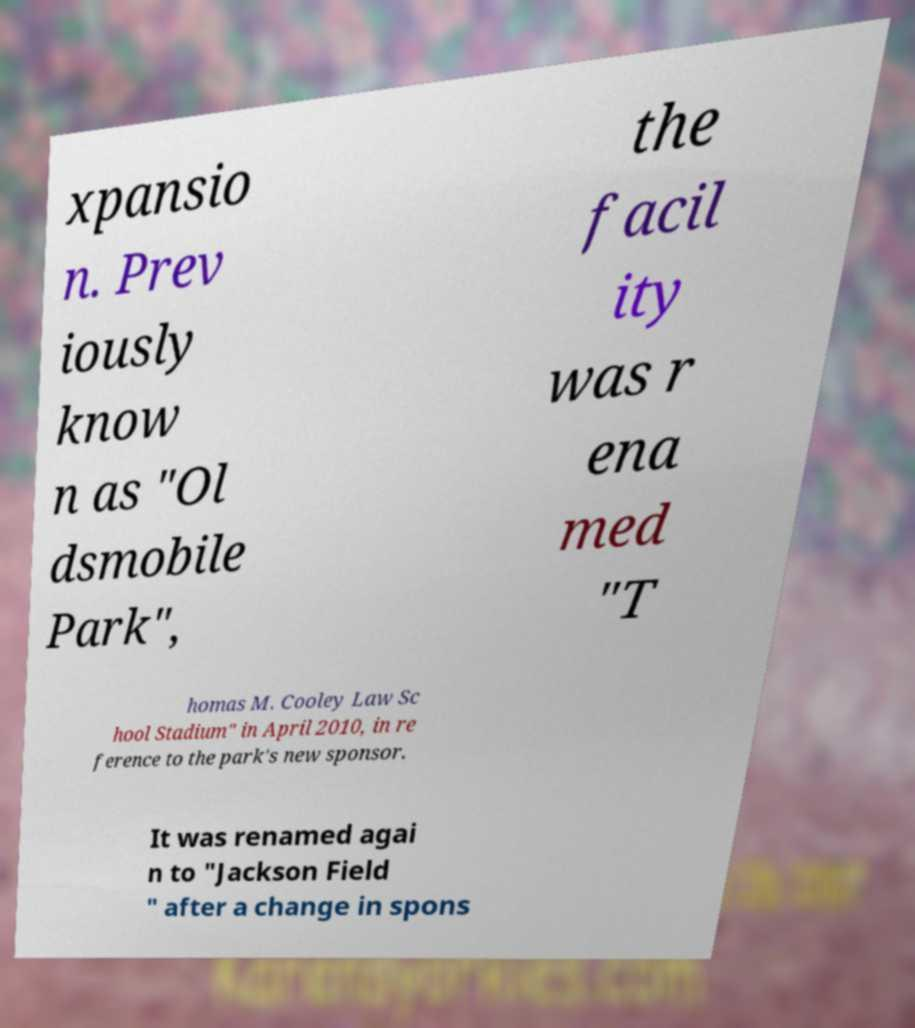For documentation purposes, I need the text within this image transcribed. Could you provide that? xpansio n. Prev iously know n as "Ol dsmobile Park", the facil ity was r ena med "T homas M. Cooley Law Sc hool Stadium" in April 2010, in re ference to the park's new sponsor. It was renamed agai n to "Jackson Field " after a change in spons 